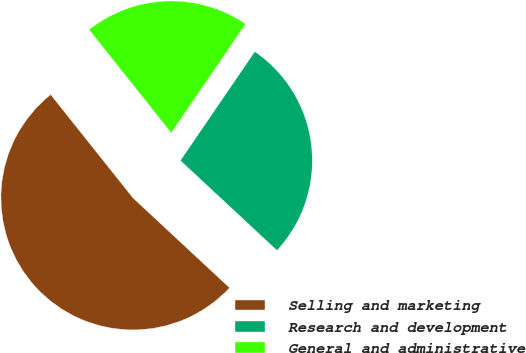Convert chart. <chart><loc_0><loc_0><loc_500><loc_500><pie_chart><fcel>Selling and marketing<fcel>Research and development<fcel>General and administrative<nl><fcel>52.37%<fcel>27.39%<fcel>20.24%<nl></chart> 